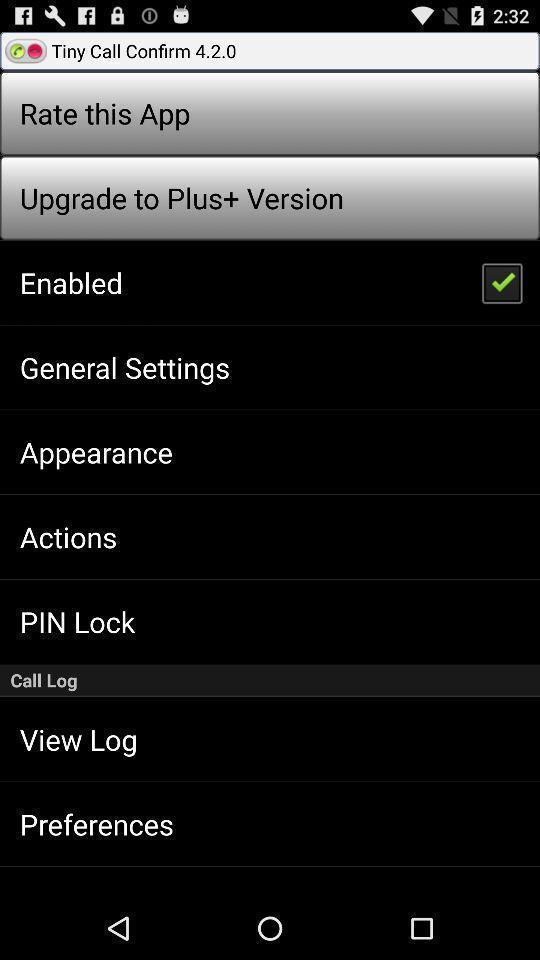Provide a description of this screenshot. Settings page of an online calling app. 